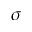<formula> <loc_0><loc_0><loc_500><loc_500>\sigma</formula> 